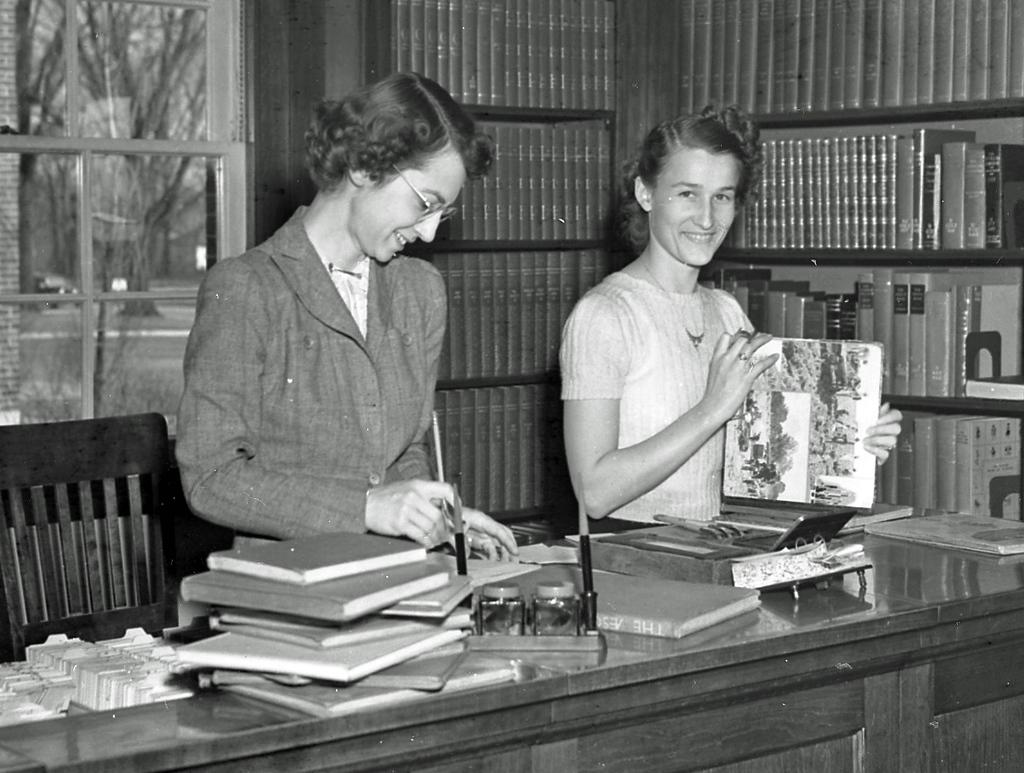How many people are in the image? There are two women in the image. What are the women doing in the image? The women are standing at a table. What objects can be seen on the table? There are books on the table. What is visible behind the women? There are shelves with books behind the women. What type of lip balm is the son using in the image? There is no son or lip balm present in the image. 